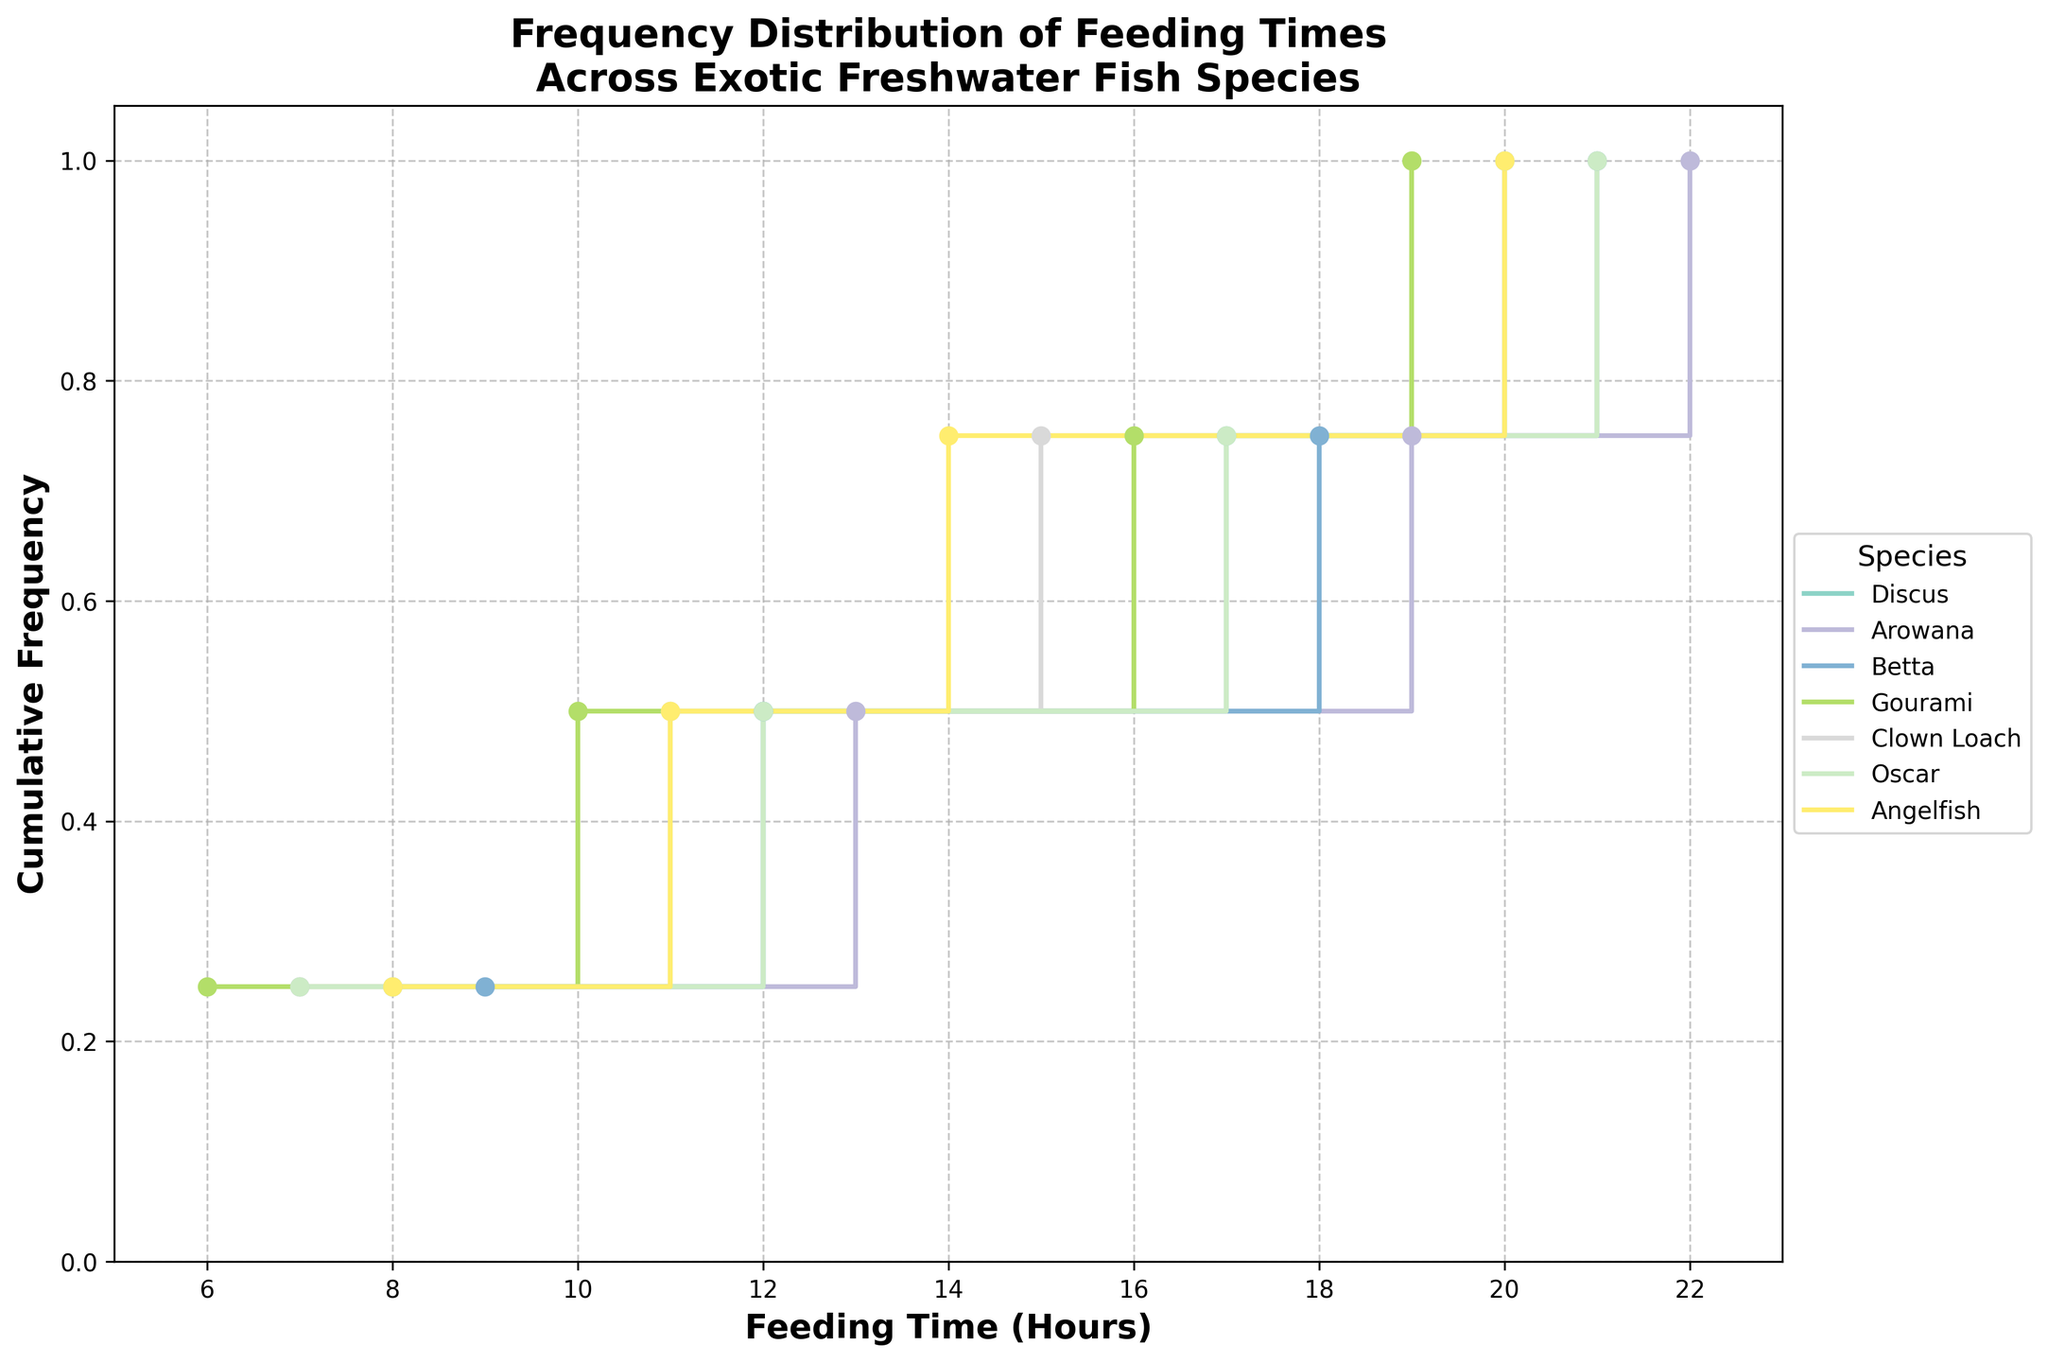What is the title of the figure? The title of the figure is displayed at the top of the plot and provides an overview of the data being visualized. It reads: "Frequency Distribution of Feeding Times Across Exotic Freshwater Fish Species".
Answer: Frequency Distribution of Feeding Times Across Exotic Freshwater Fish Species How many unique fish species are represented in the plot? The plot legend lists the different fish species, each represented by a unique color and label. By counting these labels, we can determine the number of unique species.
Answer: 6 Which fish species has feeding times at the earliest hour? By examining the x-axis, which represents feeding times, and identifying the leftmost data points (representing the earliest hours), we can determine that "Gourami" has feeding times starting at 6 AM.
Answer: Gourami What is the final cumulative frequency value for Discus? The last step in the stair plot for each species shows the final cumulative frequency value. For Discus, this value on the y-axis is 1.0, indicating all feeding times have been accounted for.
Answer: 1.0 At what hour does the cumulative frequency for Arowana reach 0.5? By tracing the step plot for Arowana (indicated by its color) to where the y-axis value reaches 0.5, we find that this occurs at the 13th hour.
Answer: 13 Which species have a feeding time at 12 hours and what is their cumulative frequency at that point? By locating the 12-hour mark on the x-axis and checking which species' step plots intersect there, we find that Discus, Betta, and Oscar all have feeding times at 12 hours. Each of these species has a cumulative frequency of 0.25 at this point.
Answer: Discus, Betta, Oscar; 0.25 Compare the range of feeding times for Betta and Oscar. Which species has a wider range? To determine the range, we look at the minimum and maximum feeding times for each species. Betta's feeding times range from 9 to 21 hours (a range of 12 hours), while Oscar's range from 7 to 21 hours (a range of 14 hours). Therefore, Oscar has a wider range of feeding times.
Answer: Oscar At what cumulative frequency do Clown Loach and Angelfish reach 20 hours of feeding time? By checking the intersection points of the step plots for Clown Loach and Angelfish at the 20-hour mark on the x-axis, we see that both species reach a cumulative frequency of 1.0 at this hour.
Answer: 1.0 Which species reaches a cumulative frequency of 0.75 first, and at what hour? By identifying the first species to reach the 0.75 value on the y-axis in the step plots, we find that Arowana reaches this cumulative frequency first at the 19th hour.
Answer: Arowana, 19 hours How many distinct feeding times does each species have? By counting the number of unique steps in each species’ stair plot, we can determine the number of distinct feeding times. Each species (Discus, Arowana, Betta, Gourami, Clown Loach, and Oscar) has 4 distinct feeding times.
Answer: 4 